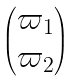<formula> <loc_0><loc_0><loc_500><loc_500>\begin{pmatrix} \varpi _ { 1 } \\ \varpi _ { 2 } \end{pmatrix}</formula> 